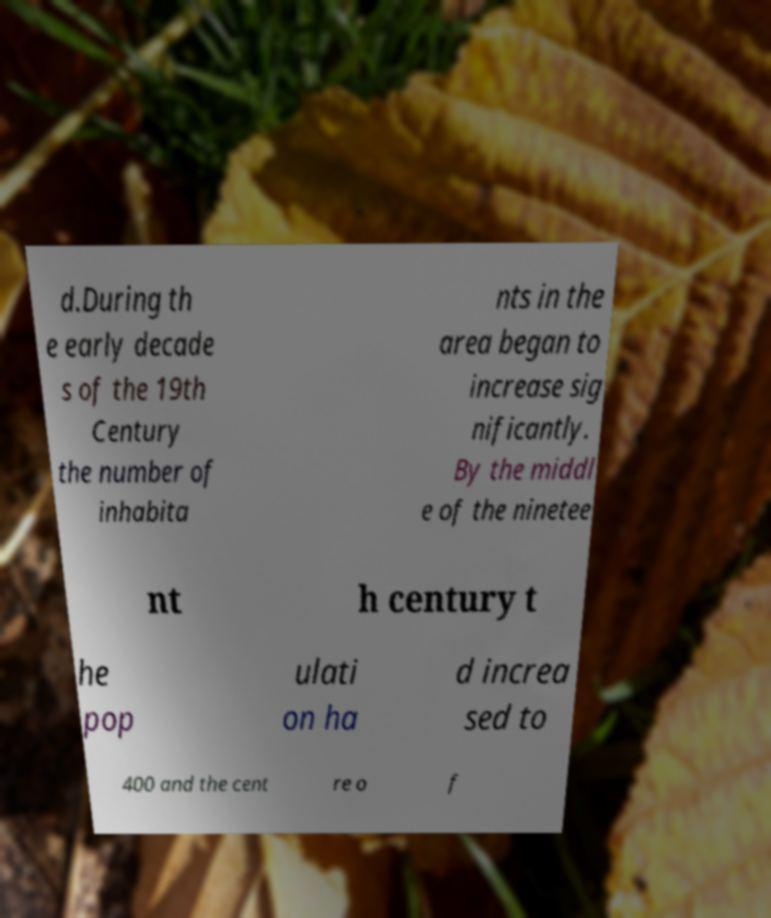For documentation purposes, I need the text within this image transcribed. Could you provide that? d.During th e early decade s of the 19th Century the number of inhabita nts in the area began to increase sig nificantly. By the middl e of the ninetee nt h century t he pop ulati on ha d increa sed to 400 and the cent re o f 